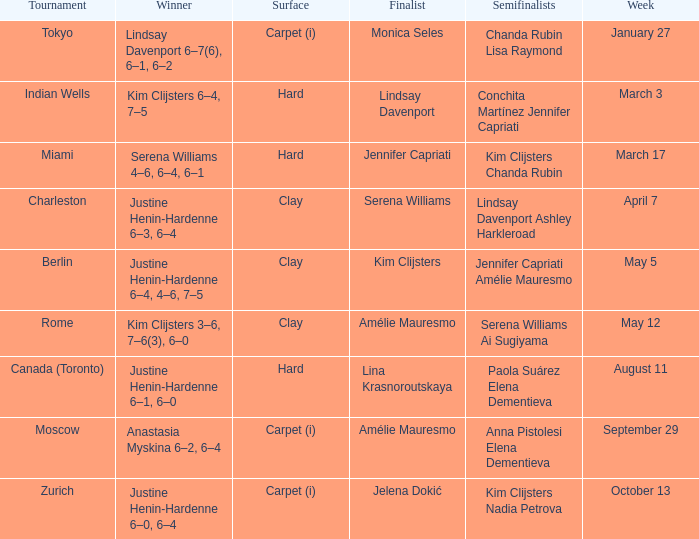Who was the finalist in Miami? Jennifer Capriati. 